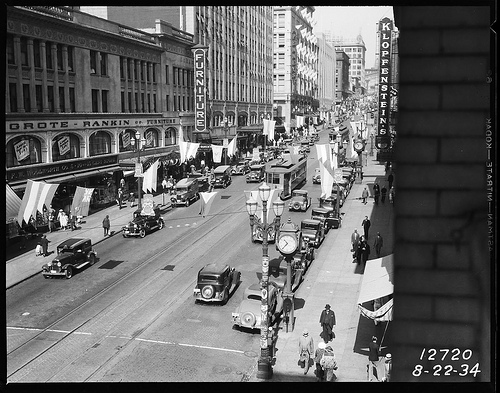Extract all visible text content from this image. FURNITURE 12720 8 22 34 KLOPFENSTEINS RANKIN OROTE 